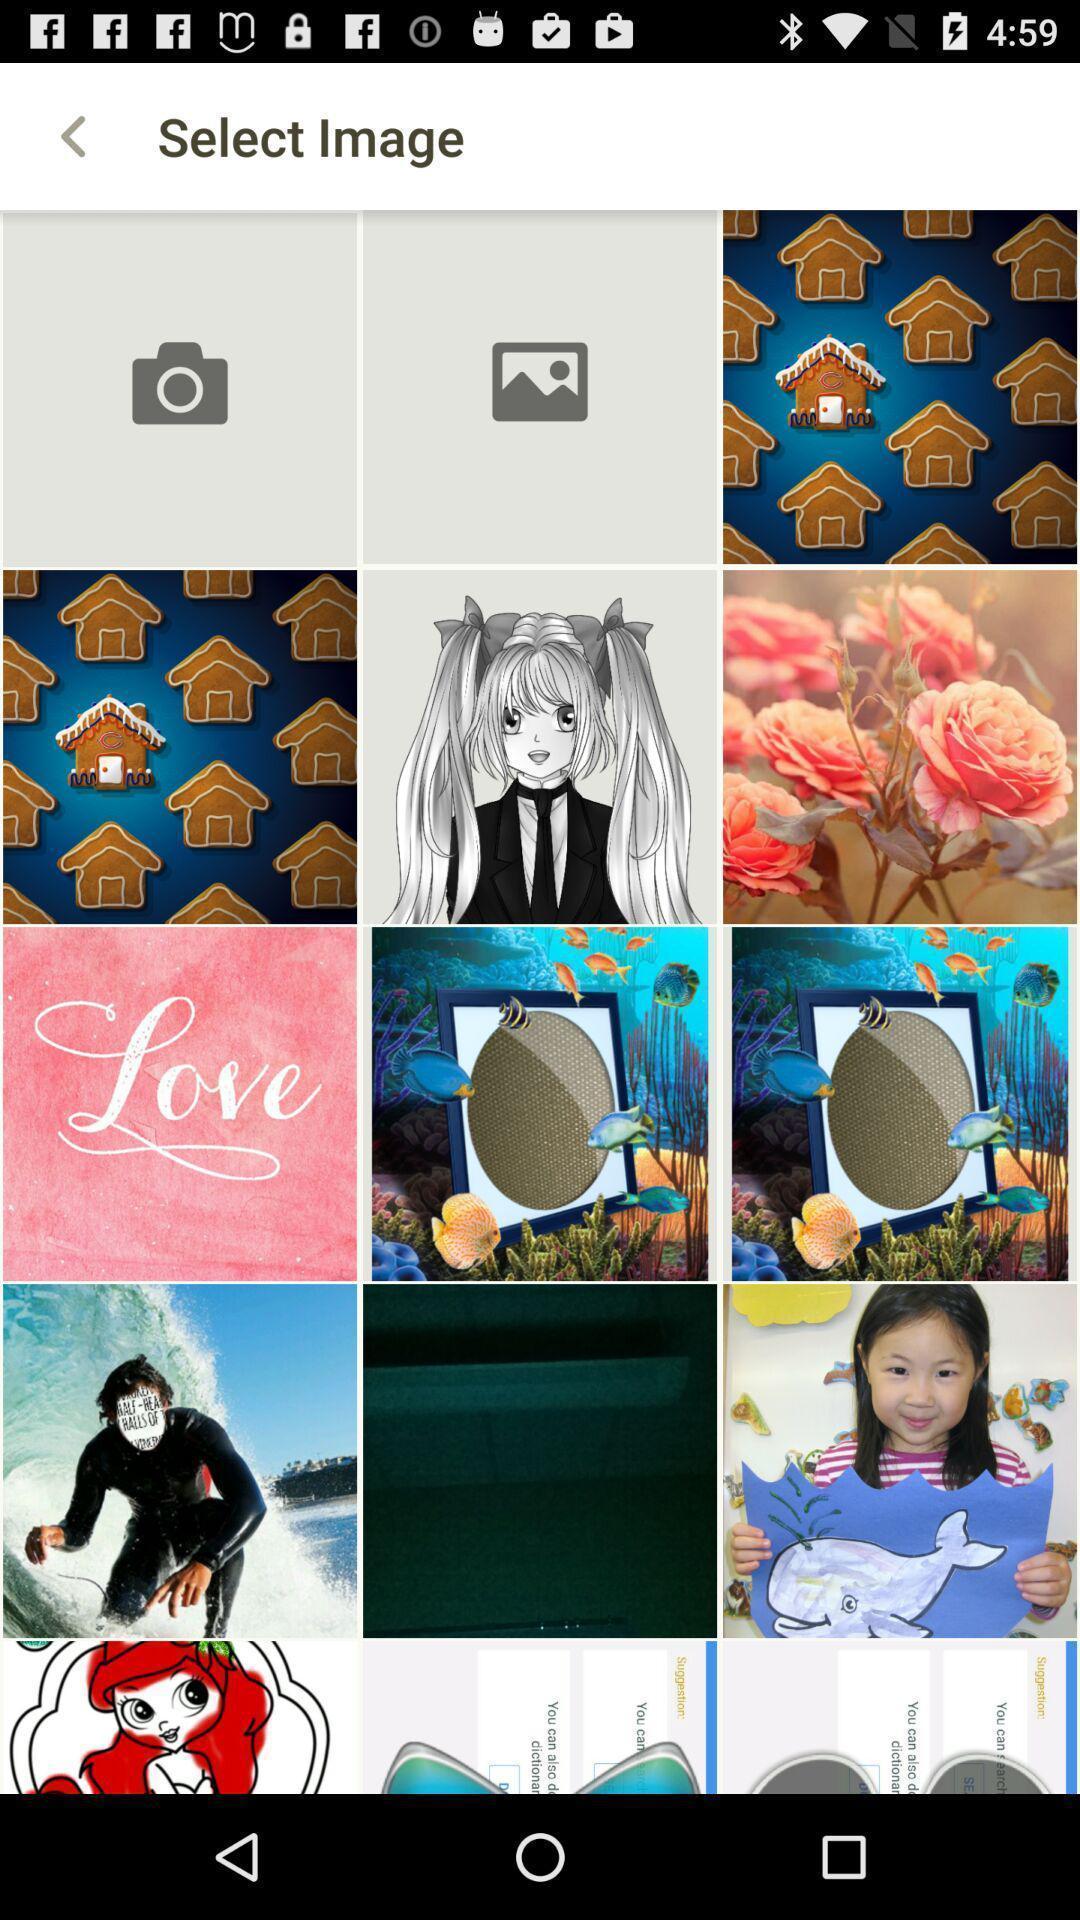What is the overall content of this screenshot? Page shows different images of application. 